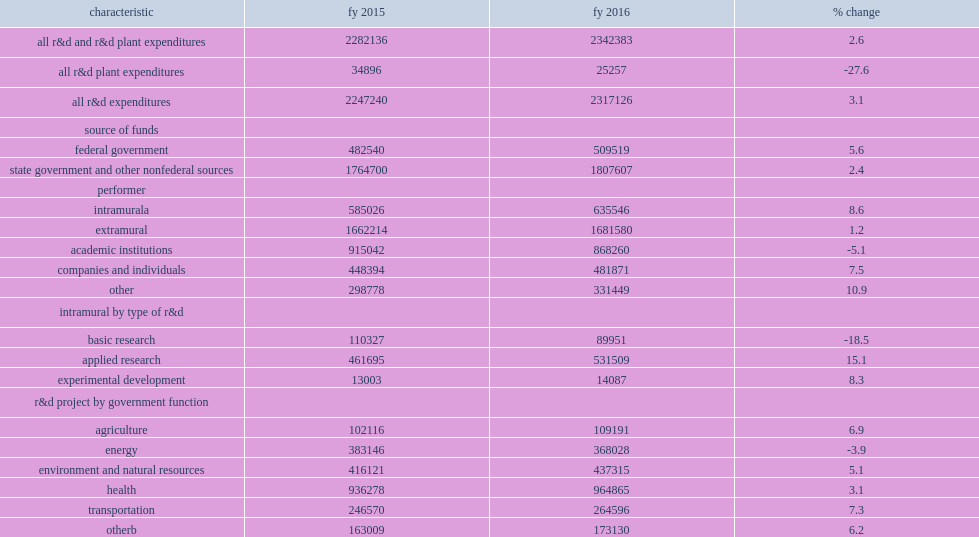How many thousand dollars did state government agency expendi- tures for research and development total in fy 2016? 2317126.0. State government agency expendi- tures for research and development totaled $2.3 billion in fy 2016, what was an increase from fy 2015? 3.1. How many thousand dollars did state government agency r&d expenditures in fy 2016 total? 2317126.0. State government agency r&d expenditures in fy 2016 totaled $2.3 billion, how many percent were came from state and other nonfederal sources? 0.780107. How many percent of the states' r&d expenditures went to extramural r&d performers in fy 2016? 0.725718. 